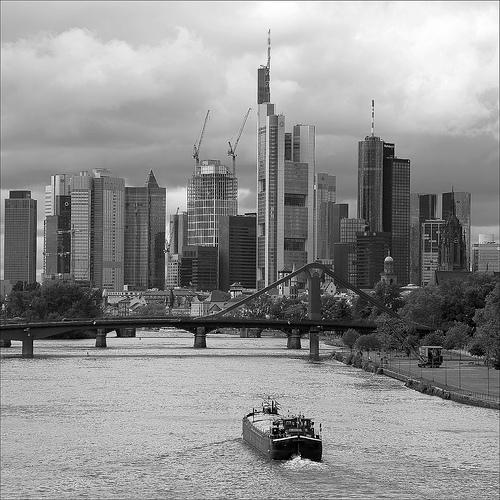Question: why are there cranes above some of the buildings?
Choices:
A. They are there for construction.
B. For a bridge.
C. For stabliity.
D. As a fortress.
Answer with the letter. Answer: A Question: who is pictured in the photo?
Choices:
A. Nobody easily visible.
B. Children.
C. Three women.
D. Three men.
Answer with the letter. Answer: A Question: how many boats are visible?
Choices:
A. One.
B. Two.
C. Three.
D. Four.
Answer with the letter. Answer: A Question: what crosses over the water?
Choices:
A. Canoe.
B. Boat.
C. Cruise ship.
D. A bridge.
Answer with the letter. Answer: D Question: what kind of weather is there?
Choices:
A. Windy.
B. Sunny.
C. Raining.
D. It is cloudy.
Answer with the letter. Answer: D 